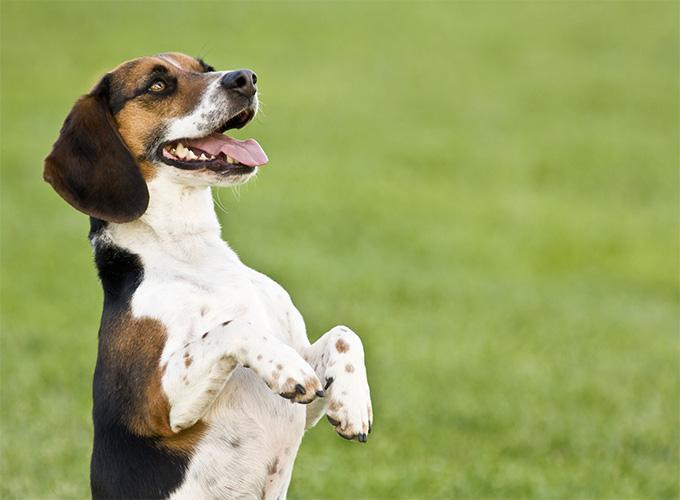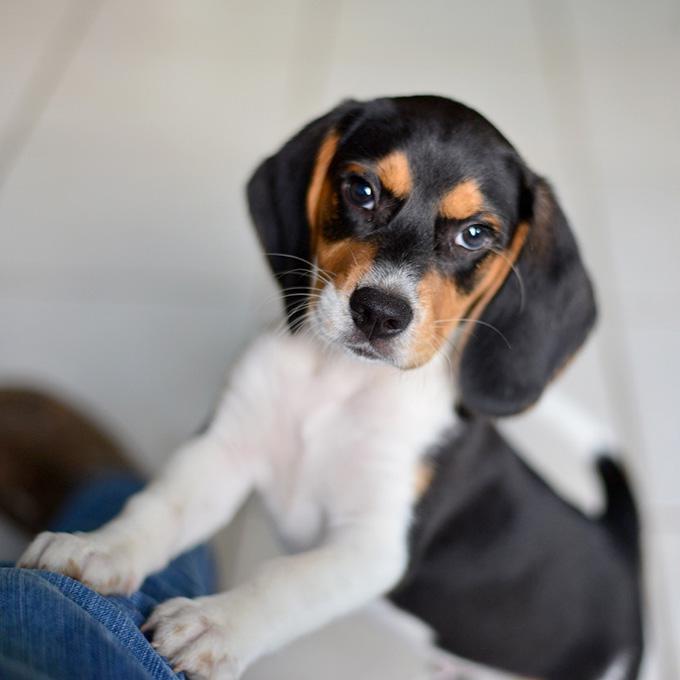The first image is the image on the left, the second image is the image on the right. Evaluate the accuracy of this statement regarding the images: "A single dog is standing on all fours in the image on the left.". Is it true? Answer yes or no. No. 